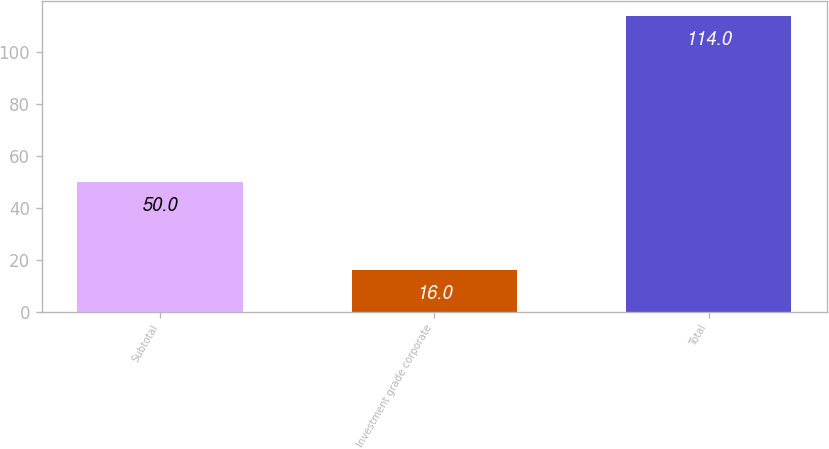<chart> <loc_0><loc_0><loc_500><loc_500><bar_chart><fcel>Subtotal<fcel>Investment grade corporate<fcel>Total<nl><fcel>50<fcel>16<fcel>114<nl></chart> 